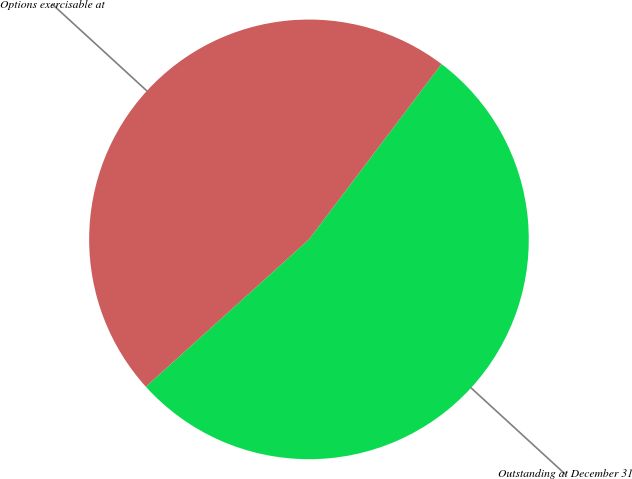<chart> <loc_0><loc_0><loc_500><loc_500><pie_chart><fcel>Outstanding at December 31<fcel>Options exercisable at<nl><fcel>53.01%<fcel>46.99%<nl></chart> 